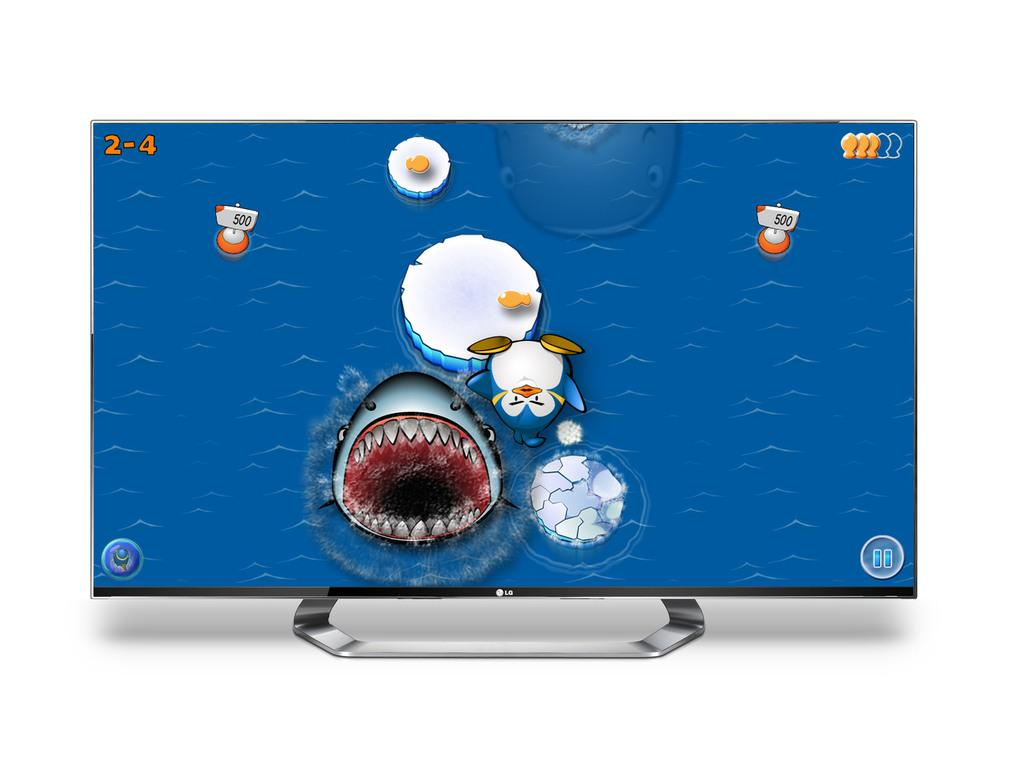<image>
Describe the image concisely. A computer game is displayed on a LG display monitor. 